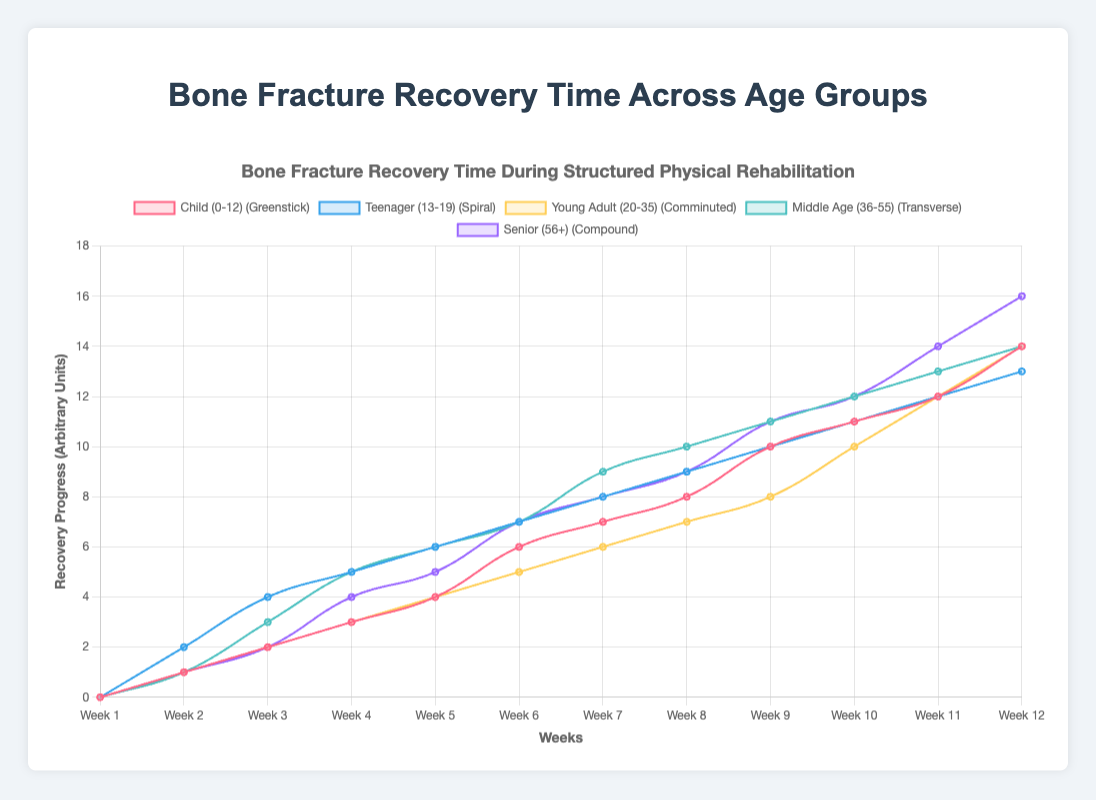Which age group shows the fastest recovery progress in the first 4 weeks? In the first 4 weeks, the Child (0-12) age group has progressed to a recovery score of 3, while the other age groups have lower values at week 4. Therefore, the Child (0-12) group shows the fastest recovery.
Answer: Child (0-12) Which fracture type has the slowest recovery time at week 12? At week 12, the Senior (56+) age group with a Compound fracture has a recovery score of 16, which is the highest and indicates the slowest recovery.
Answer: Compound Between Teenager (13-19) and Young Adult (20-35) groups, which one showed a larger recovery improvement between week 10 and week 11? For the Teenager group, the recovery increased from 11 to 12, showing an improvement of 1. For the Young Adult group, the recovery increased from 10 to 12, showing an improvement of 2. Thus, the Young Adult group showed a larger improvement.
Answer: Young Adult How does the recovery rate of the Middle Age (36-55) group compare to the Senior (56+) group at week 8? At week 8, the Middle Age group's recovery score is 10, while the Senior group's score is 9. Hence, the Middle Age group has a slightly faster recovery rate.
Answer: Middle Age What is the recovery rate trend over 12 weeks for the Teenager (13-19) age group? The Teenager group starts at 0 at week 1 and ends at 13 at week 12, showing a steady increase in recovery score.
Answer: Steady increase By how much did the Young Adult (20-35) group improve their recovery time from week 5 to week 9? The Young Adult group’s recovery score increased from 4 at week 5 to 8 at week 9, which is an improvement of 4.
Answer: 4 units Which group had a near-linear improvement in recovery from weeks 1 to 12? The Child (0-12) group showed a consistent, near-linear increase in recovery score from 0 to 14 over 12 weeks.
Answer: Child (0-12) Which age group had the most significant recovery spike in week 6? In week 6, the Child (0-12) group had a notable spike in recovery score, jumping from 4 to 6 in just one week.
Answer: Child (0-12) What is the difference in recovery progress between the Middle Age (36-55) and Young Adult (20-35) groups at week 7? At week 7, the Middle Age group's recovery score is 9, while the Young Adult group's score is 6. The difference in recovery progress is 3 units.
Answer: 3 units How does the recovery progress of the Child (0-12) group at week 10 compare to that of the Senior (56+) group? At week 10, the Child (0-12) group has a recovery score of 11, while the Senior (56+) group has a score of 12. Hence, the Senior group is slightly ahead.
Answer: Senior 